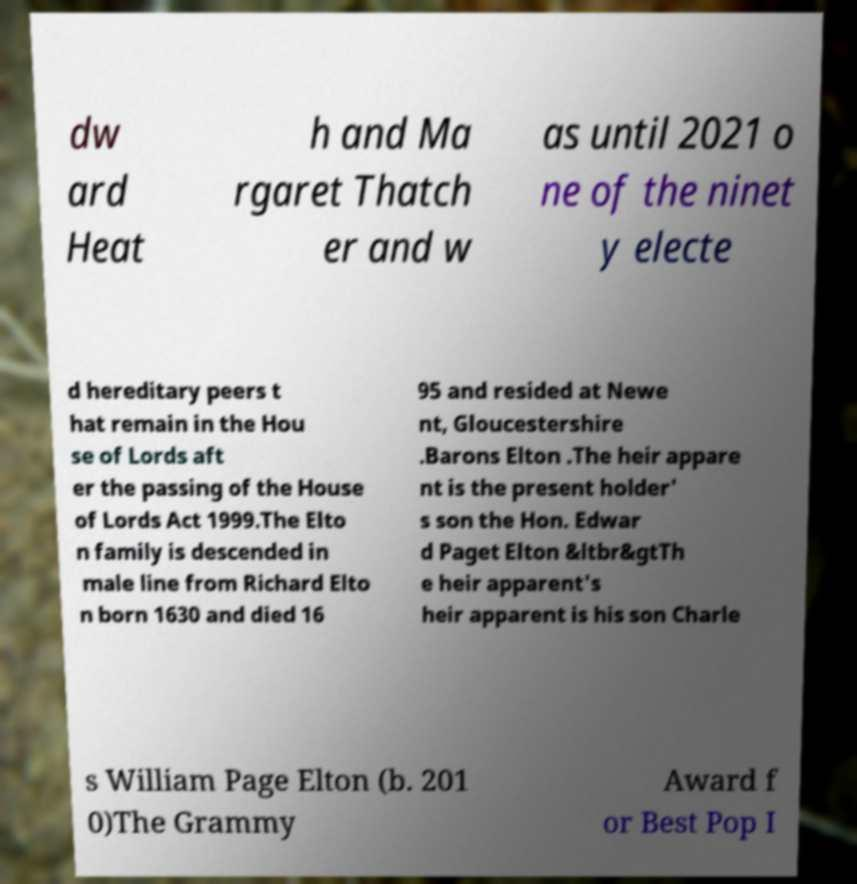Can you accurately transcribe the text from the provided image for me? dw ard Heat h and Ma rgaret Thatch er and w as until 2021 o ne of the ninet y electe d hereditary peers t hat remain in the Hou se of Lords aft er the passing of the House of Lords Act 1999.The Elto n family is descended in male line from Richard Elto n born 1630 and died 16 95 and resided at Newe nt, Gloucestershire .Barons Elton .The heir appare nt is the present holder' s son the Hon. Edwar d Paget Elton &ltbr&gtTh e heir apparent's heir apparent is his son Charle s William Page Elton (b. 201 0)The Grammy Award f or Best Pop I 